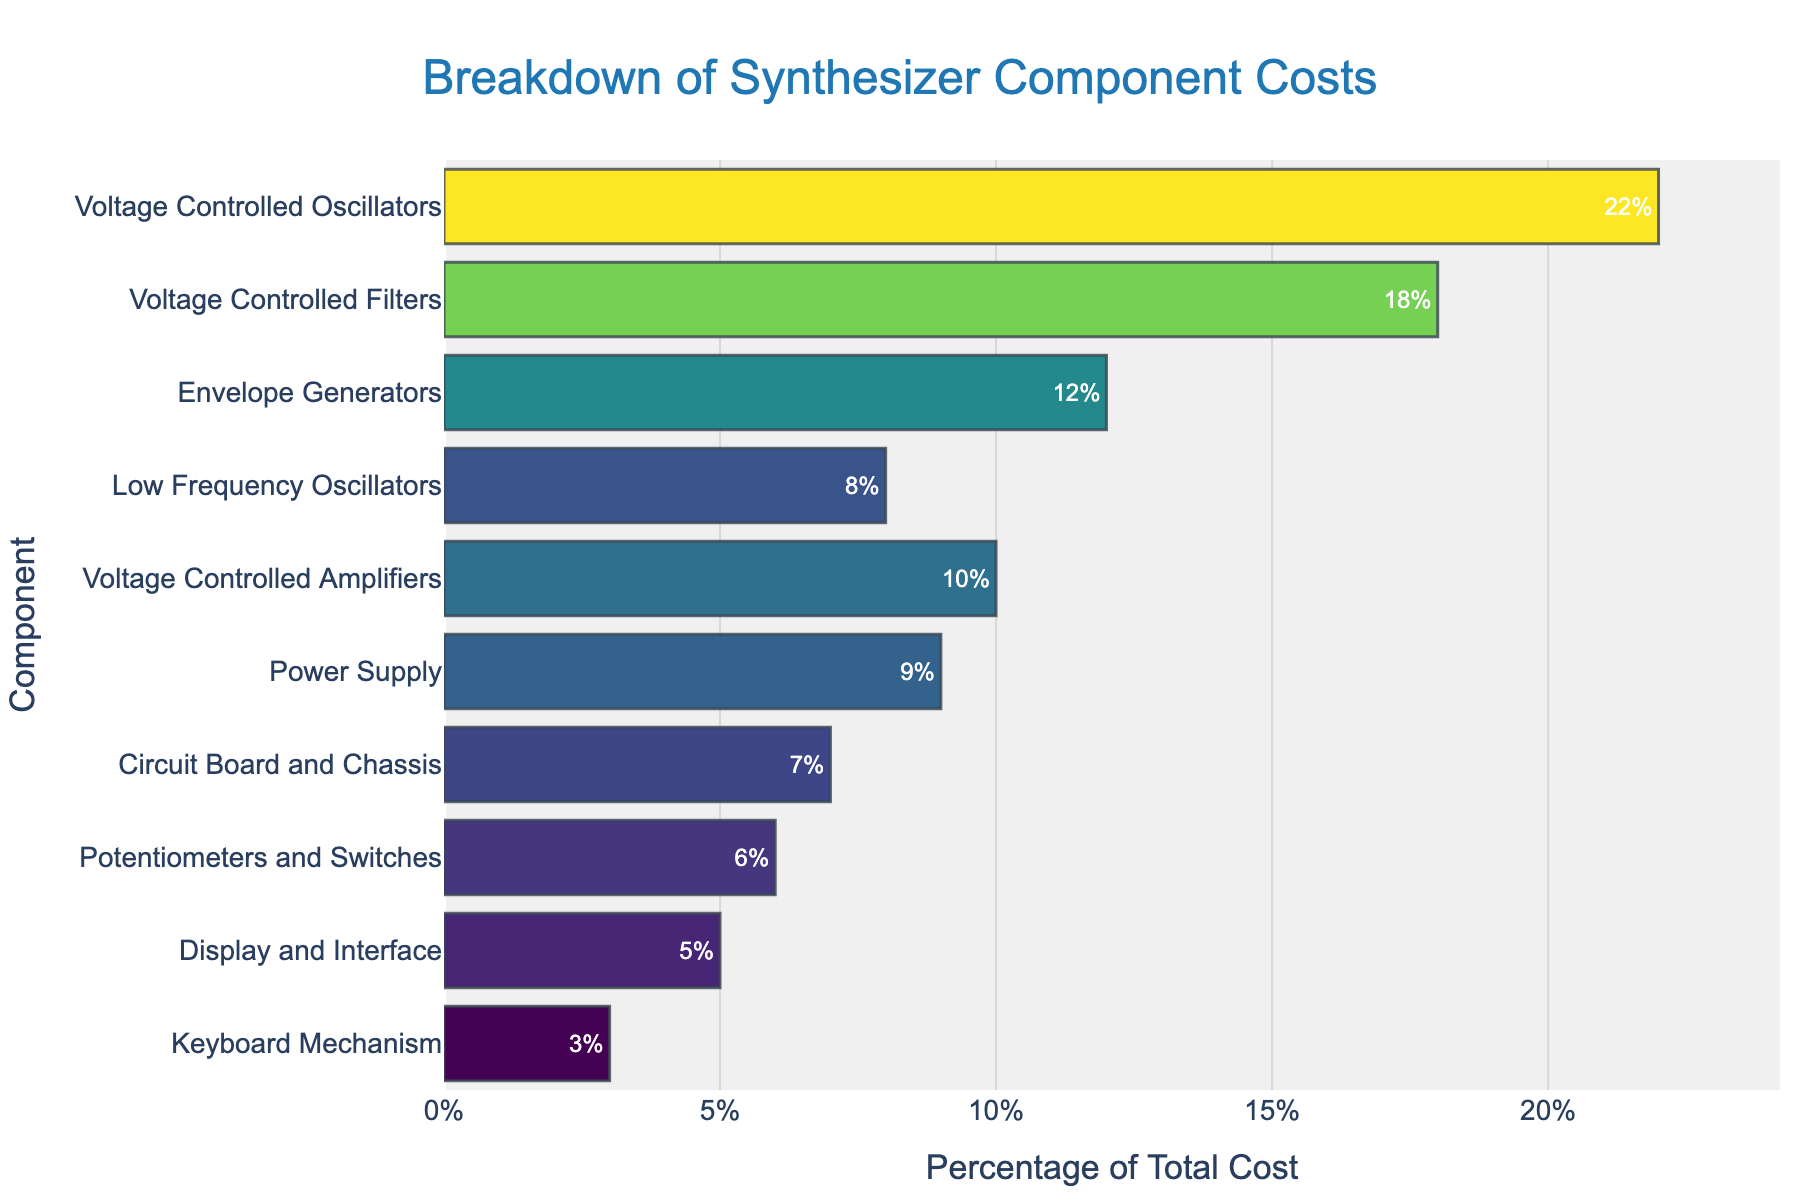What is the most expensive component? By visually inspecting the bar chart, the Voltage Controlled Oscillators (VCO) have the highest percentage of total cost at 22%.
Answer: Voltage Controlled Oscillators Which component has the lowest percentage of total cost? The Keyboard Mechanism has the shortest bar indicating the lowest percentage of total cost at 3%.
Answer: Keyboard Mechanism What is the combined percentage of total cost for the Envelope Generators and Voltage Controlled Amplifiers? Envelope Generators have 12% and Voltage Controlled Amplifiers have 10%. Adding these gives 12% + 10% = 22%.
Answer: 22% How much greater is the cost percentage of Voltage Controlled Oscillators compared to the Envelope Generators? Voltage Controlled Oscillators have a cost percentage of 22%, and Envelope Generators have 12%. 22% - 12% = 10%.
Answer: 10% Which component has a higher percentage of total cost, the Power Supply or Circuit Board and Chassis? The Power Supply has 9% of the total cost whereas Circuit Board and Chassis have 7%. Therefore, the Power Supply has a higher percentage.
Answer: Power Supply If you group the components into two categories: more than 10% and 10% or less, how many components fall into each category? Components more than 10%: Voltage Controlled Oscillators, Voltage Controlled Filters, Envelope Generators (3 components). Components 10% or less: Low Frequency Oscillators, Voltage Controlled Amplifiers, Power Supply, Circuit Board and Chassis, Potentiometers and Switches, Display and Interface, Keyboard Mechanism (7 components).
Answer: 3 and 7 Are there more components that fall below the 10% cost mark, or above it? There are 7 components below the 10% cost mark and 3 components above it.
Answer: Below What's the average percentage of the total cost for Voltage Controlled Oscillators, Voltage Controlled Filters, and Envelope Generators combined? The combined cost percentage for the three components is 22% + 18% + 12% = 52%. The average is 52% / 3 = 17.33%.
Answer: 17.33% Between which two components is the cost difference the smallest? By visually comparing the lengths of the bars, the smallest difference is between the Power Supply (9%) and Circuit Board and Chassis (7%) with a difference of 2%.
Answer: Power Supply and Circuit Board and Chassis What percentage of the total manufacturing cost is accounted for by the top three most expensive components? The top three most expensive components are Voltage Controlled Oscillators (22%), Voltage Controlled Filters (18%), and Envelope Generators (12%). Adding these gives 22% + 18% + 12% = 52%.
Answer: 52% 